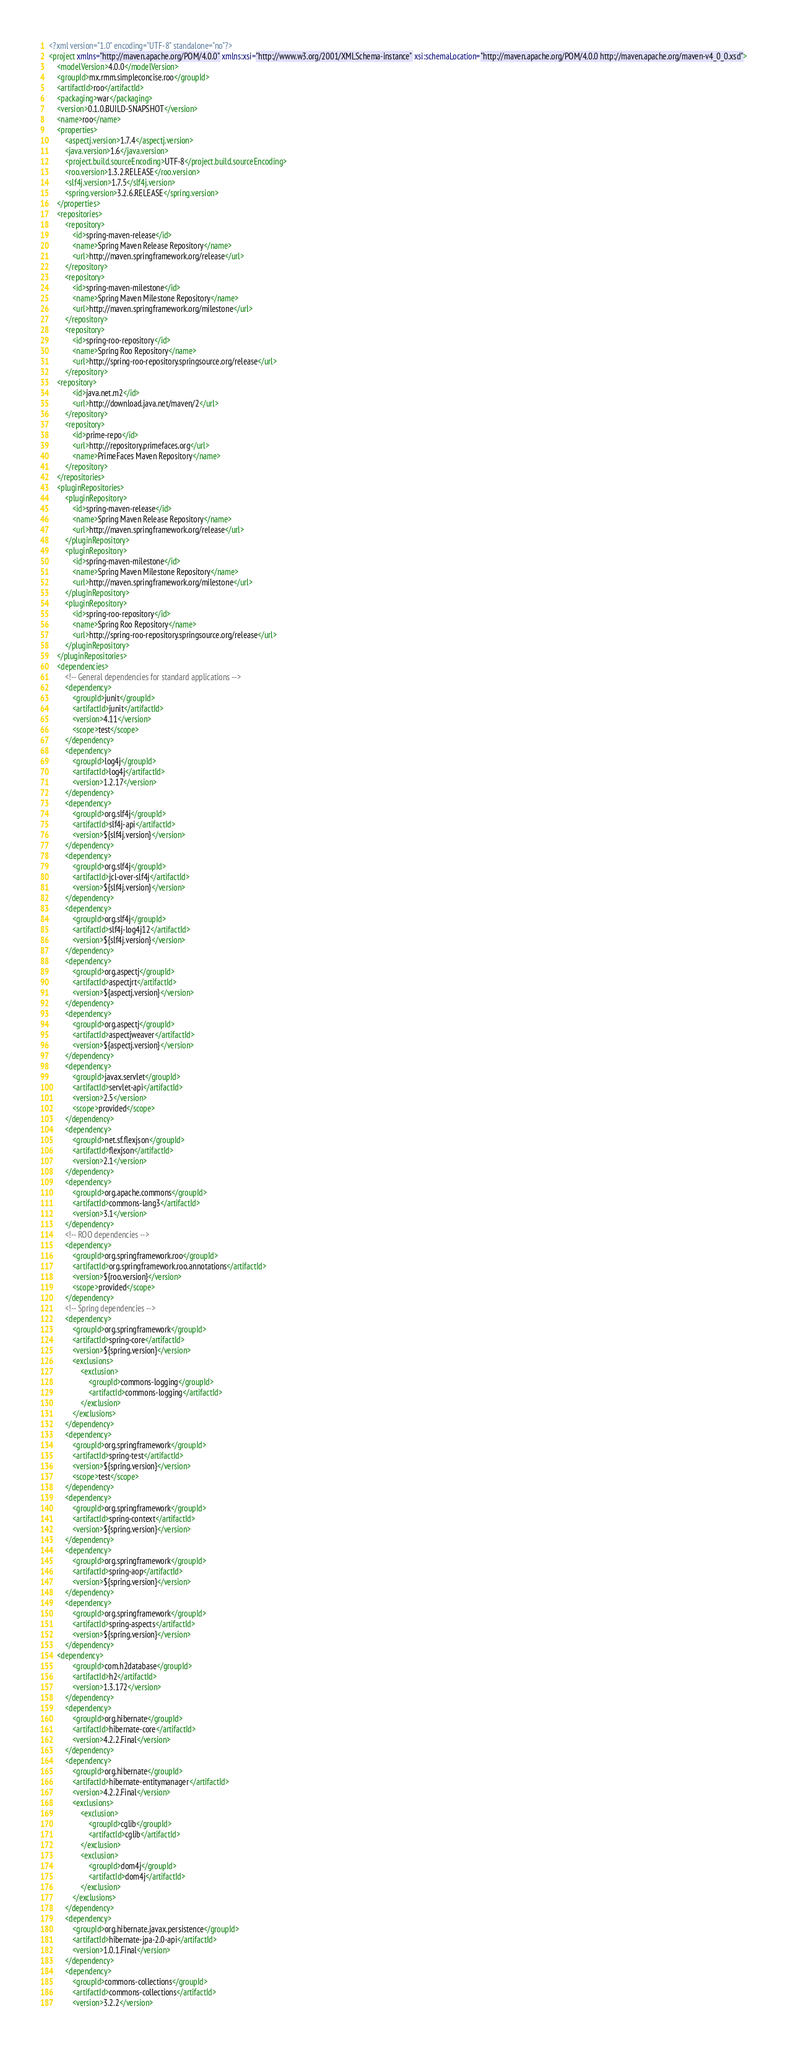Convert code to text. <code><loc_0><loc_0><loc_500><loc_500><_XML_><?xml version="1.0" encoding="UTF-8" standalone="no"?>
<project xmlns="http://maven.apache.org/POM/4.0.0" xmlns:xsi="http://www.w3.org/2001/XMLSchema-instance" xsi:schemaLocation="http://maven.apache.org/POM/4.0.0 http://maven.apache.org/maven-v4_0_0.xsd">
    <modelVersion>4.0.0</modelVersion>
    <groupId>mx.rmm.simpleconcise.roo</groupId>
    <artifactId>roo</artifactId>
    <packaging>war</packaging>
    <version>0.1.0.BUILD-SNAPSHOT</version>
    <name>roo</name>
    <properties>
        <aspectj.version>1.7.4</aspectj.version>
        <java.version>1.6</java.version>
        <project.build.sourceEncoding>UTF-8</project.build.sourceEncoding>
        <roo.version>1.3.2.RELEASE</roo.version>
        <slf4j.version>1.7.5</slf4j.version>
        <spring.version>3.2.6.RELEASE</spring.version>
    </properties>
    <repositories>
        <repository>
            <id>spring-maven-release</id>
            <name>Spring Maven Release Repository</name>
            <url>http://maven.springframework.org/release</url>
        </repository>
        <repository>
            <id>spring-maven-milestone</id>
            <name>Spring Maven Milestone Repository</name>
            <url>http://maven.springframework.org/milestone</url>
        </repository>
        <repository>
            <id>spring-roo-repository</id>
            <name>Spring Roo Repository</name>
            <url>http://spring-roo-repository.springsource.org/release</url>
        </repository>
    <repository>
            <id>java.net.m2</id>
            <url>http://download.java.net/maven/2</url>
        </repository>
        <repository>
            <id>prime-repo</id>
            <url>http://repository.primefaces.org</url>
            <name>PrimeFaces Maven Repository</name>
        </repository>
    </repositories>
    <pluginRepositories>
        <pluginRepository>
            <id>spring-maven-release</id>
            <name>Spring Maven Release Repository</name>
            <url>http://maven.springframework.org/release</url>
        </pluginRepository>
        <pluginRepository>
            <id>spring-maven-milestone</id>
            <name>Spring Maven Milestone Repository</name>
            <url>http://maven.springframework.org/milestone</url>
        </pluginRepository>
        <pluginRepository>
            <id>spring-roo-repository</id>
            <name>Spring Roo Repository</name>
            <url>http://spring-roo-repository.springsource.org/release</url>
        </pluginRepository>
    </pluginRepositories>
    <dependencies>
        <!-- General dependencies for standard applications -->
        <dependency>
            <groupId>junit</groupId>
            <artifactId>junit</artifactId>
            <version>4.11</version>
            <scope>test</scope>
        </dependency>
        <dependency>
            <groupId>log4j</groupId>
            <artifactId>log4j</artifactId>
            <version>1.2.17</version>
        </dependency>
        <dependency>
            <groupId>org.slf4j</groupId>
            <artifactId>slf4j-api</artifactId>
            <version>${slf4j.version}</version>
        </dependency>
        <dependency>
            <groupId>org.slf4j</groupId>
            <artifactId>jcl-over-slf4j</artifactId>
            <version>${slf4j.version}</version>
        </dependency>
        <dependency>
            <groupId>org.slf4j</groupId>
            <artifactId>slf4j-log4j12</artifactId>
            <version>${slf4j.version}</version>
        </dependency>
        <dependency>
            <groupId>org.aspectj</groupId>
            <artifactId>aspectjrt</artifactId>
            <version>${aspectj.version}</version>
        </dependency>
        <dependency>
            <groupId>org.aspectj</groupId>
            <artifactId>aspectjweaver</artifactId>
            <version>${aspectj.version}</version>
        </dependency>
        <dependency>
            <groupId>javax.servlet</groupId>
            <artifactId>servlet-api</artifactId>
            <version>2.5</version>
            <scope>provided</scope>
        </dependency>
        <dependency>
            <groupId>net.sf.flexjson</groupId>
            <artifactId>flexjson</artifactId>
            <version>2.1</version>
        </dependency>
        <dependency>
            <groupId>org.apache.commons</groupId>
            <artifactId>commons-lang3</artifactId>
            <version>3.1</version>
        </dependency>
        <!-- ROO dependencies -->
        <dependency>
            <groupId>org.springframework.roo</groupId>
            <artifactId>org.springframework.roo.annotations</artifactId>
            <version>${roo.version}</version>
            <scope>provided</scope>
        </dependency>
        <!-- Spring dependencies -->
        <dependency>
            <groupId>org.springframework</groupId>
            <artifactId>spring-core</artifactId>
            <version>${spring.version}</version>
            <exclusions>
                <exclusion>
                    <groupId>commons-logging</groupId>
                    <artifactId>commons-logging</artifactId>
                </exclusion>
            </exclusions>
        </dependency>
        <dependency>
            <groupId>org.springframework</groupId>
            <artifactId>spring-test</artifactId>
            <version>${spring.version}</version>
            <scope>test</scope>
        </dependency>
        <dependency>
            <groupId>org.springframework</groupId>
            <artifactId>spring-context</artifactId>
            <version>${spring.version}</version>
        </dependency>
        <dependency>
            <groupId>org.springframework</groupId>
            <artifactId>spring-aop</artifactId>
            <version>${spring.version}</version>
        </dependency>
        <dependency>
            <groupId>org.springframework</groupId>
            <artifactId>spring-aspects</artifactId>
            <version>${spring.version}</version>
        </dependency>
    <dependency>
            <groupId>com.h2database</groupId>
            <artifactId>h2</artifactId>
            <version>1.3.172</version>
        </dependency>
        <dependency>
            <groupId>org.hibernate</groupId>
            <artifactId>hibernate-core</artifactId>
            <version>4.2.2.Final</version>
        </dependency>
        <dependency>
            <groupId>org.hibernate</groupId>
            <artifactId>hibernate-entitymanager</artifactId>
            <version>4.2.2.Final</version>
            <exclusions>
                <exclusion>
                    <groupId>cglib</groupId>
                    <artifactId>cglib</artifactId>
                </exclusion>
                <exclusion>
                    <groupId>dom4j</groupId>
                    <artifactId>dom4j</artifactId>
                </exclusion>
            </exclusions>
        </dependency>
        <dependency>
            <groupId>org.hibernate.javax.persistence</groupId>
            <artifactId>hibernate-jpa-2.0-api</artifactId>
            <version>1.0.1.Final</version>
        </dependency>
        <dependency>
            <groupId>commons-collections</groupId>
            <artifactId>commons-collections</artifactId>
            <version>3.2.2</version></code> 